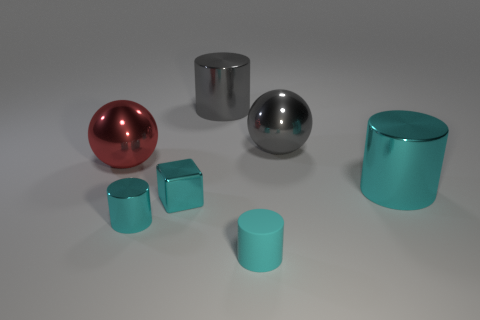How many cyan cylinders must be subtracted to get 2 cyan cylinders? 1 Add 2 tiny cylinders. How many objects exist? 9 Subtract all small matte cylinders. How many cylinders are left? 3 Subtract 3 cylinders. How many cylinders are left? 1 Add 7 gray shiny balls. How many gray shiny balls exist? 8 Subtract all cyan cylinders. How many cylinders are left? 1 Subtract 0 yellow cylinders. How many objects are left? 7 Subtract all cylinders. How many objects are left? 3 Subtract all cyan cylinders. Subtract all cyan balls. How many cylinders are left? 1 Subtract all purple spheres. How many red cylinders are left? 0 